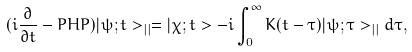Convert formula to latex. <formula><loc_0><loc_0><loc_500><loc_500>( i \frac { \partial } { \partial t } - P H P ) | \psi ; t > _ { | | } = | \chi ; t > - i \int _ { 0 } ^ { \infty } K ( t - \tau ) | \psi ; \tau > _ { | | } d \tau ,</formula> 